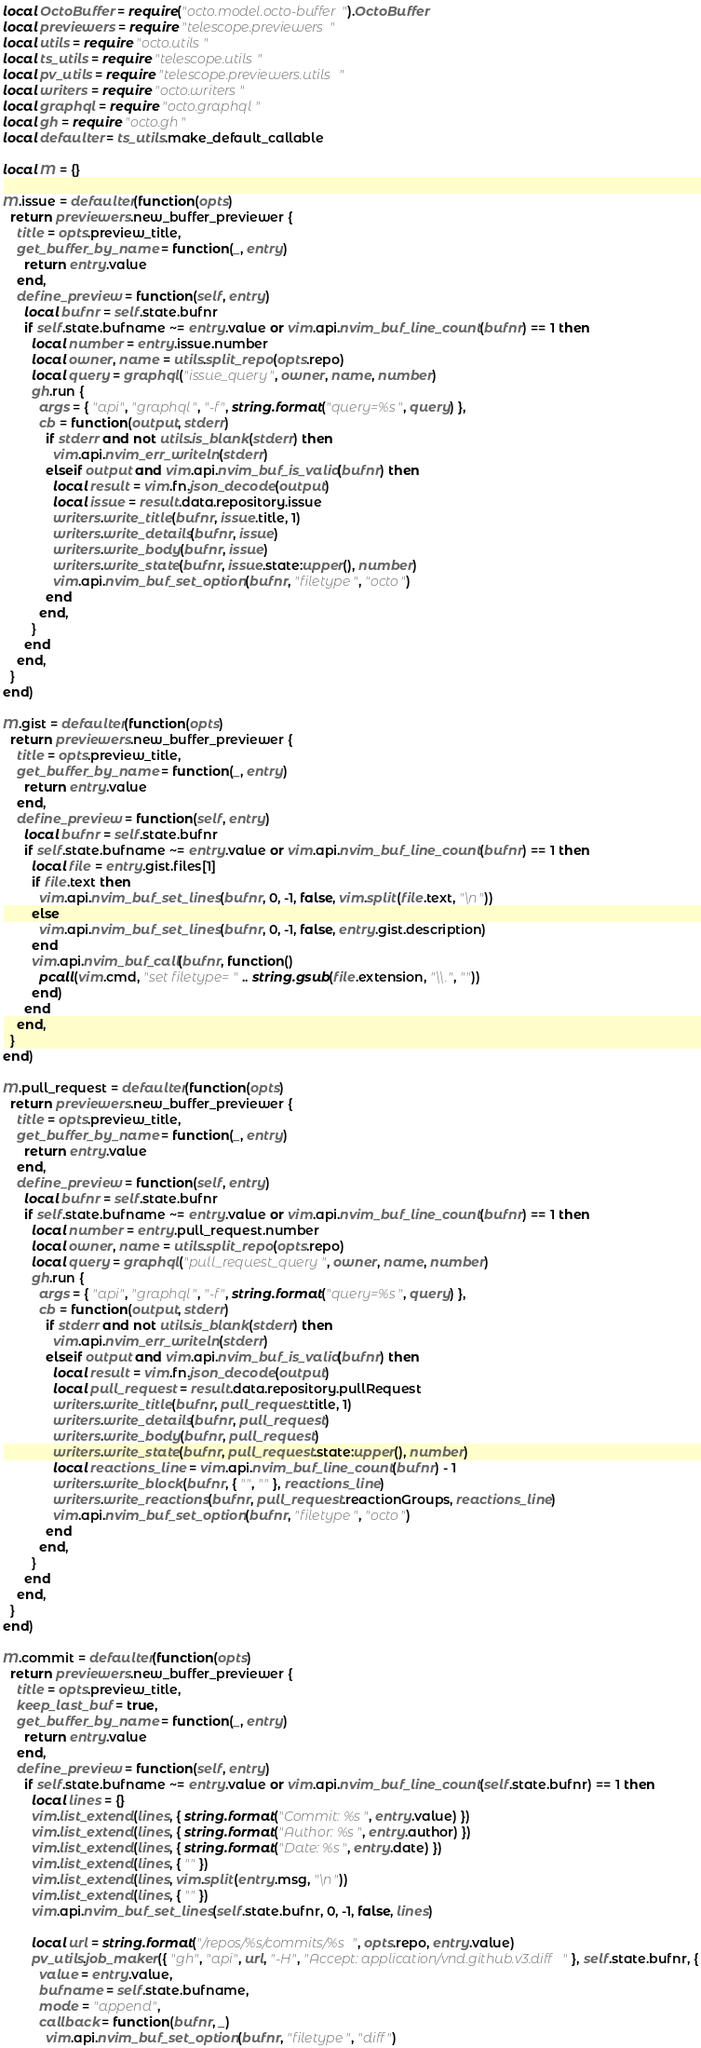<code> <loc_0><loc_0><loc_500><loc_500><_Lua_>local OctoBuffer = require("octo.model.octo-buffer").OctoBuffer
local previewers = require "telescope.previewers"
local utils = require "octo.utils"
local ts_utils = require "telescope.utils"
local pv_utils = require "telescope.previewers.utils"
local writers = require "octo.writers"
local graphql = require "octo.graphql"
local gh = require "octo.gh"
local defaulter = ts_utils.make_default_callable

local M = {}

M.issue = defaulter(function(opts)
  return previewers.new_buffer_previewer {
    title = opts.preview_title,
    get_buffer_by_name = function(_, entry)
      return entry.value
    end,
    define_preview = function(self, entry)
      local bufnr = self.state.bufnr
      if self.state.bufname ~= entry.value or vim.api.nvim_buf_line_count(bufnr) == 1 then
        local number = entry.issue.number
        local owner, name = utils.split_repo(opts.repo)
        local query = graphql("issue_query", owner, name, number)
        gh.run {
          args = { "api", "graphql", "-f", string.format("query=%s", query) },
          cb = function(output, stderr)
            if stderr and not utils.is_blank(stderr) then
              vim.api.nvim_err_writeln(stderr)
            elseif output and vim.api.nvim_buf_is_valid(bufnr) then
              local result = vim.fn.json_decode(output)
              local issue = result.data.repository.issue
              writers.write_title(bufnr, issue.title, 1)
              writers.write_details(bufnr, issue)
              writers.write_body(bufnr, issue)
              writers.write_state(bufnr, issue.state:upper(), number)
              vim.api.nvim_buf_set_option(bufnr, "filetype", "octo")
            end
          end,
        }
      end
    end,
  }
end)

M.gist = defaulter(function(opts)
  return previewers.new_buffer_previewer {
    title = opts.preview_title,
    get_buffer_by_name = function(_, entry)
      return entry.value
    end,
    define_preview = function(self, entry)
      local bufnr = self.state.bufnr
      if self.state.bufname ~= entry.value or vim.api.nvim_buf_line_count(bufnr) == 1 then
        local file = entry.gist.files[1]
        if file.text then
          vim.api.nvim_buf_set_lines(bufnr, 0, -1, false, vim.split(file.text, "\n"))
        else
          vim.api.nvim_buf_set_lines(bufnr, 0, -1, false, entry.gist.description)
        end
        vim.api.nvim_buf_call(bufnr, function()
          pcall(vim.cmd, "set filetype=" .. string.gsub(file.extension, "\\.", ""))
        end)
      end
    end,
  }
end)

M.pull_request = defaulter(function(opts)
  return previewers.new_buffer_previewer {
    title = opts.preview_title,
    get_buffer_by_name = function(_, entry)
      return entry.value
    end,
    define_preview = function(self, entry)
      local bufnr = self.state.bufnr
      if self.state.bufname ~= entry.value or vim.api.nvim_buf_line_count(bufnr) == 1 then
        local number = entry.pull_request.number
        local owner, name = utils.split_repo(opts.repo)
        local query = graphql("pull_request_query", owner, name, number)
        gh.run {
          args = { "api", "graphql", "-f", string.format("query=%s", query) },
          cb = function(output, stderr)
            if stderr and not utils.is_blank(stderr) then
              vim.api.nvim_err_writeln(stderr)
            elseif output and vim.api.nvim_buf_is_valid(bufnr) then
              local result = vim.fn.json_decode(output)
              local pull_request = result.data.repository.pullRequest
              writers.write_title(bufnr, pull_request.title, 1)
              writers.write_details(bufnr, pull_request)
              writers.write_body(bufnr, pull_request)
              writers.write_state(bufnr, pull_request.state:upper(), number)
              local reactions_line = vim.api.nvim_buf_line_count(bufnr) - 1
              writers.write_block(bufnr, { "", "" }, reactions_line)
              writers.write_reactions(bufnr, pull_request.reactionGroups, reactions_line)
              vim.api.nvim_buf_set_option(bufnr, "filetype", "octo")
            end
          end,
        }
      end
    end,
  }
end)

M.commit = defaulter(function(opts)
  return previewers.new_buffer_previewer {
    title = opts.preview_title,
    keep_last_buf = true,
    get_buffer_by_name = function(_, entry)
      return entry.value
    end,
    define_preview = function(self, entry)
      if self.state.bufname ~= entry.value or vim.api.nvim_buf_line_count(self.state.bufnr) == 1 then
        local lines = {}
        vim.list_extend(lines, { string.format("Commit: %s", entry.value) })
        vim.list_extend(lines, { string.format("Author: %s", entry.author) })
        vim.list_extend(lines, { string.format("Date: %s", entry.date) })
        vim.list_extend(lines, { "" })
        vim.list_extend(lines, vim.split(entry.msg, "\n"))
        vim.list_extend(lines, { "" })
        vim.api.nvim_buf_set_lines(self.state.bufnr, 0, -1, false, lines)

        local url = string.format("/repos/%s/commits/%s", opts.repo, entry.value)
        pv_utils.job_maker({ "gh", "api", url, "-H", "Accept: application/vnd.github.v3.diff" }, self.state.bufnr, {
          value = entry.value,
          bufname = self.state.bufname,
          mode = "append",
          callback = function(bufnr, _)
            vim.api.nvim_buf_set_option(bufnr, "filetype", "diff")</code> 